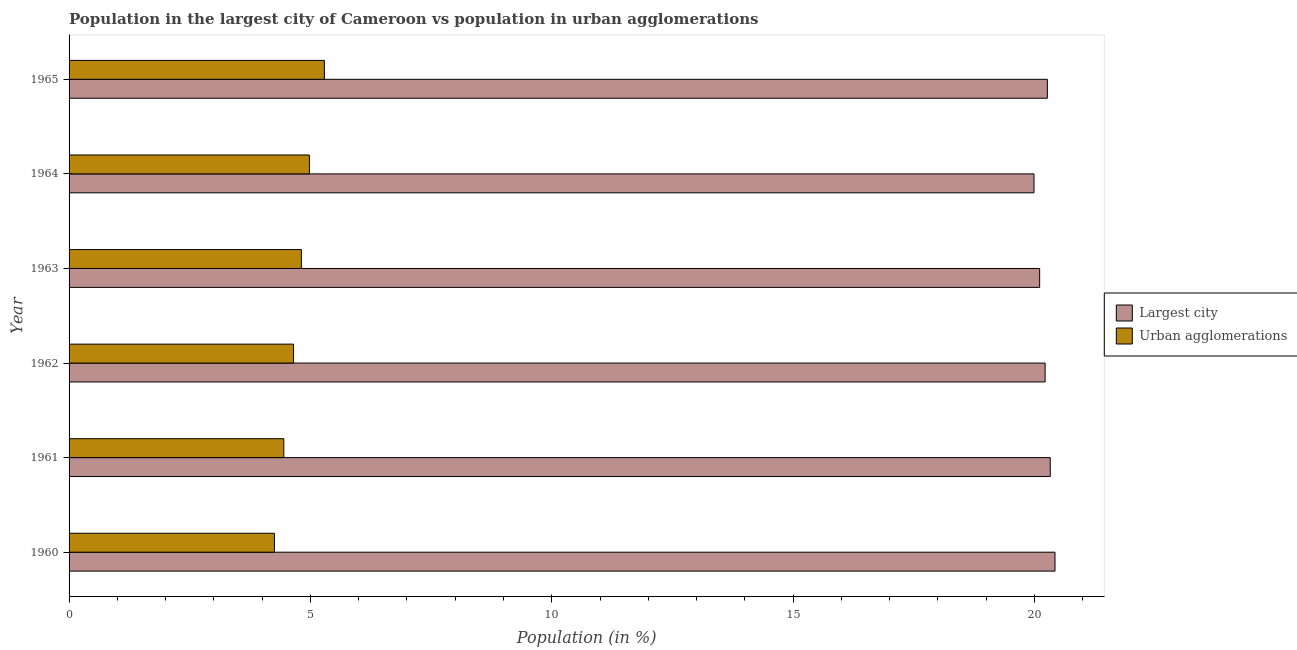How many groups of bars are there?
Provide a short and direct response. 6. Are the number of bars per tick equal to the number of legend labels?
Your answer should be very brief. Yes. Are the number of bars on each tick of the Y-axis equal?
Give a very brief answer. Yes. How many bars are there on the 4th tick from the top?
Give a very brief answer. 2. What is the label of the 2nd group of bars from the top?
Make the answer very short. 1964. What is the population in urban agglomerations in 1964?
Give a very brief answer. 4.98. Across all years, what is the maximum population in urban agglomerations?
Ensure brevity in your answer.  5.29. Across all years, what is the minimum population in the largest city?
Offer a terse response. 19.99. In which year was the population in the largest city maximum?
Make the answer very short. 1960. What is the total population in the largest city in the graph?
Provide a succinct answer. 121.33. What is the difference between the population in urban agglomerations in 1963 and that in 1965?
Give a very brief answer. -0.48. What is the difference between the population in urban agglomerations in 1961 and the population in the largest city in 1965?
Your answer should be compact. -15.82. What is the average population in the largest city per year?
Keep it short and to the point. 20.22. In the year 1963, what is the difference between the population in urban agglomerations and population in the largest city?
Offer a very short reply. -15.29. In how many years, is the population in urban agglomerations greater than 4 %?
Keep it short and to the point. 6. What is the ratio of the population in the largest city in 1960 to that in 1963?
Offer a very short reply. 1.02. Is the population in urban agglomerations in 1964 less than that in 1965?
Provide a short and direct response. Yes. Is the difference between the population in the largest city in 1961 and 1964 greater than the difference between the population in urban agglomerations in 1961 and 1964?
Keep it short and to the point. Yes. What is the difference between the highest and the second highest population in the largest city?
Ensure brevity in your answer.  0.1. What is the difference between the highest and the lowest population in the largest city?
Keep it short and to the point. 0.43. Is the sum of the population in the largest city in 1962 and 1965 greater than the maximum population in urban agglomerations across all years?
Offer a terse response. Yes. What does the 2nd bar from the top in 1963 represents?
Provide a short and direct response. Largest city. What does the 2nd bar from the bottom in 1963 represents?
Offer a terse response. Urban agglomerations. How many bars are there?
Offer a very short reply. 12. Does the graph contain any zero values?
Your response must be concise. No. How many legend labels are there?
Your answer should be very brief. 2. What is the title of the graph?
Ensure brevity in your answer.  Population in the largest city of Cameroon vs population in urban agglomerations. Does "Study and work" appear as one of the legend labels in the graph?
Provide a short and direct response. No. What is the label or title of the X-axis?
Make the answer very short. Population (in %). What is the label or title of the Y-axis?
Keep it short and to the point. Year. What is the Population (in %) of Largest city in 1960?
Provide a short and direct response. 20.42. What is the Population (in %) in Urban agglomerations in 1960?
Make the answer very short. 4.25. What is the Population (in %) in Largest city in 1961?
Keep it short and to the point. 20.33. What is the Population (in %) of Urban agglomerations in 1961?
Offer a very short reply. 4.45. What is the Population (in %) in Largest city in 1962?
Your answer should be compact. 20.22. What is the Population (in %) in Urban agglomerations in 1962?
Give a very brief answer. 4.65. What is the Population (in %) of Largest city in 1963?
Keep it short and to the point. 20.11. What is the Population (in %) of Urban agglomerations in 1963?
Provide a succinct answer. 4.81. What is the Population (in %) in Largest city in 1964?
Provide a succinct answer. 19.99. What is the Population (in %) of Urban agglomerations in 1964?
Your answer should be compact. 4.98. What is the Population (in %) in Largest city in 1965?
Make the answer very short. 20.27. What is the Population (in %) in Urban agglomerations in 1965?
Offer a terse response. 5.29. Across all years, what is the maximum Population (in %) of Largest city?
Give a very brief answer. 20.42. Across all years, what is the maximum Population (in %) in Urban agglomerations?
Ensure brevity in your answer.  5.29. Across all years, what is the minimum Population (in %) of Largest city?
Provide a short and direct response. 19.99. Across all years, what is the minimum Population (in %) of Urban agglomerations?
Provide a short and direct response. 4.25. What is the total Population (in %) in Largest city in the graph?
Ensure brevity in your answer.  121.33. What is the total Population (in %) of Urban agglomerations in the graph?
Provide a short and direct response. 28.43. What is the difference between the Population (in %) of Largest city in 1960 and that in 1961?
Give a very brief answer. 0.1. What is the difference between the Population (in %) in Urban agglomerations in 1960 and that in 1961?
Offer a very short reply. -0.19. What is the difference between the Population (in %) in Largest city in 1960 and that in 1962?
Keep it short and to the point. 0.2. What is the difference between the Population (in %) in Urban agglomerations in 1960 and that in 1962?
Your response must be concise. -0.4. What is the difference between the Population (in %) of Largest city in 1960 and that in 1963?
Offer a terse response. 0.32. What is the difference between the Population (in %) in Urban agglomerations in 1960 and that in 1963?
Your response must be concise. -0.56. What is the difference between the Population (in %) of Largest city in 1960 and that in 1964?
Ensure brevity in your answer.  0.43. What is the difference between the Population (in %) in Urban agglomerations in 1960 and that in 1964?
Your answer should be compact. -0.72. What is the difference between the Population (in %) of Largest city in 1960 and that in 1965?
Offer a very short reply. 0.16. What is the difference between the Population (in %) of Urban agglomerations in 1960 and that in 1965?
Provide a succinct answer. -1.04. What is the difference between the Population (in %) in Largest city in 1961 and that in 1962?
Make the answer very short. 0.11. What is the difference between the Population (in %) in Urban agglomerations in 1961 and that in 1962?
Your response must be concise. -0.2. What is the difference between the Population (in %) in Largest city in 1961 and that in 1963?
Make the answer very short. 0.22. What is the difference between the Population (in %) of Urban agglomerations in 1961 and that in 1963?
Provide a succinct answer. -0.36. What is the difference between the Population (in %) in Largest city in 1961 and that in 1964?
Your answer should be compact. 0.34. What is the difference between the Population (in %) in Urban agglomerations in 1961 and that in 1964?
Your answer should be compact. -0.53. What is the difference between the Population (in %) in Largest city in 1961 and that in 1965?
Give a very brief answer. 0.06. What is the difference between the Population (in %) in Urban agglomerations in 1961 and that in 1965?
Provide a short and direct response. -0.84. What is the difference between the Population (in %) in Largest city in 1962 and that in 1963?
Your response must be concise. 0.11. What is the difference between the Population (in %) of Urban agglomerations in 1962 and that in 1963?
Ensure brevity in your answer.  -0.16. What is the difference between the Population (in %) in Largest city in 1962 and that in 1964?
Give a very brief answer. 0.23. What is the difference between the Population (in %) in Urban agglomerations in 1962 and that in 1964?
Give a very brief answer. -0.33. What is the difference between the Population (in %) in Largest city in 1962 and that in 1965?
Offer a terse response. -0.05. What is the difference between the Population (in %) of Urban agglomerations in 1962 and that in 1965?
Offer a terse response. -0.64. What is the difference between the Population (in %) in Largest city in 1963 and that in 1964?
Provide a short and direct response. 0.12. What is the difference between the Population (in %) of Urban agglomerations in 1963 and that in 1964?
Offer a terse response. -0.17. What is the difference between the Population (in %) of Largest city in 1963 and that in 1965?
Keep it short and to the point. -0.16. What is the difference between the Population (in %) of Urban agglomerations in 1963 and that in 1965?
Keep it short and to the point. -0.48. What is the difference between the Population (in %) in Largest city in 1964 and that in 1965?
Make the answer very short. -0.28. What is the difference between the Population (in %) in Urban agglomerations in 1964 and that in 1965?
Provide a short and direct response. -0.31. What is the difference between the Population (in %) in Largest city in 1960 and the Population (in %) in Urban agglomerations in 1961?
Provide a succinct answer. 15.98. What is the difference between the Population (in %) in Largest city in 1960 and the Population (in %) in Urban agglomerations in 1962?
Your answer should be compact. 15.77. What is the difference between the Population (in %) in Largest city in 1960 and the Population (in %) in Urban agglomerations in 1963?
Ensure brevity in your answer.  15.61. What is the difference between the Population (in %) in Largest city in 1960 and the Population (in %) in Urban agglomerations in 1964?
Ensure brevity in your answer.  15.45. What is the difference between the Population (in %) in Largest city in 1960 and the Population (in %) in Urban agglomerations in 1965?
Your response must be concise. 15.13. What is the difference between the Population (in %) in Largest city in 1961 and the Population (in %) in Urban agglomerations in 1962?
Your answer should be very brief. 15.68. What is the difference between the Population (in %) of Largest city in 1961 and the Population (in %) of Urban agglomerations in 1963?
Make the answer very short. 15.51. What is the difference between the Population (in %) of Largest city in 1961 and the Population (in %) of Urban agglomerations in 1964?
Keep it short and to the point. 15.35. What is the difference between the Population (in %) of Largest city in 1961 and the Population (in %) of Urban agglomerations in 1965?
Your answer should be compact. 15.04. What is the difference between the Population (in %) in Largest city in 1962 and the Population (in %) in Urban agglomerations in 1963?
Make the answer very short. 15.41. What is the difference between the Population (in %) in Largest city in 1962 and the Population (in %) in Urban agglomerations in 1964?
Keep it short and to the point. 15.24. What is the difference between the Population (in %) of Largest city in 1962 and the Population (in %) of Urban agglomerations in 1965?
Your answer should be very brief. 14.93. What is the difference between the Population (in %) of Largest city in 1963 and the Population (in %) of Urban agglomerations in 1964?
Your answer should be compact. 15.13. What is the difference between the Population (in %) of Largest city in 1963 and the Population (in %) of Urban agglomerations in 1965?
Make the answer very short. 14.82. What is the difference between the Population (in %) in Largest city in 1964 and the Population (in %) in Urban agglomerations in 1965?
Your answer should be compact. 14.7. What is the average Population (in %) in Largest city per year?
Provide a succinct answer. 20.22. What is the average Population (in %) in Urban agglomerations per year?
Provide a short and direct response. 4.74. In the year 1960, what is the difference between the Population (in %) of Largest city and Population (in %) of Urban agglomerations?
Keep it short and to the point. 16.17. In the year 1961, what is the difference between the Population (in %) in Largest city and Population (in %) in Urban agglomerations?
Provide a succinct answer. 15.88. In the year 1962, what is the difference between the Population (in %) of Largest city and Population (in %) of Urban agglomerations?
Ensure brevity in your answer.  15.57. In the year 1963, what is the difference between the Population (in %) of Largest city and Population (in %) of Urban agglomerations?
Your response must be concise. 15.29. In the year 1964, what is the difference between the Population (in %) in Largest city and Population (in %) in Urban agglomerations?
Your answer should be very brief. 15.01. In the year 1965, what is the difference between the Population (in %) of Largest city and Population (in %) of Urban agglomerations?
Keep it short and to the point. 14.98. What is the ratio of the Population (in %) in Largest city in 1960 to that in 1961?
Provide a succinct answer. 1. What is the ratio of the Population (in %) in Urban agglomerations in 1960 to that in 1961?
Ensure brevity in your answer.  0.96. What is the ratio of the Population (in %) in Urban agglomerations in 1960 to that in 1962?
Offer a very short reply. 0.91. What is the ratio of the Population (in %) of Largest city in 1960 to that in 1963?
Your answer should be compact. 1.02. What is the ratio of the Population (in %) in Urban agglomerations in 1960 to that in 1963?
Keep it short and to the point. 0.88. What is the ratio of the Population (in %) of Largest city in 1960 to that in 1964?
Give a very brief answer. 1.02. What is the ratio of the Population (in %) of Urban agglomerations in 1960 to that in 1964?
Offer a very short reply. 0.85. What is the ratio of the Population (in %) in Urban agglomerations in 1960 to that in 1965?
Offer a terse response. 0.8. What is the ratio of the Population (in %) of Urban agglomerations in 1961 to that in 1962?
Give a very brief answer. 0.96. What is the ratio of the Population (in %) of Largest city in 1961 to that in 1963?
Provide a short and direct response. 1.01. What is the ratio of the Population (in %) in Urban agglomerations in 1961 to that in 1963?
Your response must be concise. 0.92. What is the ratio of the Population (in %) of Largest city in 1961 to that in 1964?
Ensure brevity in your answer.  1.02. What is the ratio of the Population (in %) in Urban agglomerations in 1961 to that in 1964?
Give a very brief answer. 0.89. What is the ratio of the Population (in %) in Urban agglomerations in 1961 to that in 1965?
Make the answer very short. 0.84. What is the ratio of the Population (in %) of Largest city in 1962 to that in 1963?
Your answer should be very brief. 1.01. What is the ratio of the Population (in %) in Urban agglomerations in 1962 to that in 1963?
Make the answer very short. 0.97. What is the ratio of the Population (in %) of Largest city in 1962 to that in 1964?
Offer a very short reply. 1.01. What is the ratio of the Population (in %) of Urban agglomerations in 1962 to that in 1964?
Keep it short and to the point. 0.93. What is the ratio of the Population (in %) of Urban agglomerations in 1962 to that in 1965?
Provide a succinct answer. 0.88. What is the ratio of the Population (in %) of Largest city in 1963 to that in 1964?
Keep it short and to the point. 1.01. What is the ratio of the Population (in %) of Urban agglomerations in 1963 to that in 1964?
Make the answer very short. 0.97. What is the ratio of the Population (in %) in Urban agglomerations in 1963 to that in 1965?
Ensure brevity in your answer.  0.91. What is the ratio of the Population (in %) in Largest city in 1964 to that in 1965?
Give a very brief answer. 0.99. What is the ratio of the Population (in %) in Urban agglomerations in 1964 to that in 1965?
Keep it short and to the point. 0.94. What is the difference between the highest and the second highest Population (in %) in Largest city?
Keep it short and to the point. 0.1. What is the difference between the highest and the second highest Population (in %) of Urban agglomerations?
Make the answer very short. 0.31. What is the difference between the highest and the lowest Population (in %) of Largest city?
Your response must be concise. 0.43. What is the difference between the highest and the lowest Population (in %) in Urban agglomerations?
Offer a terse response. 1.04. 